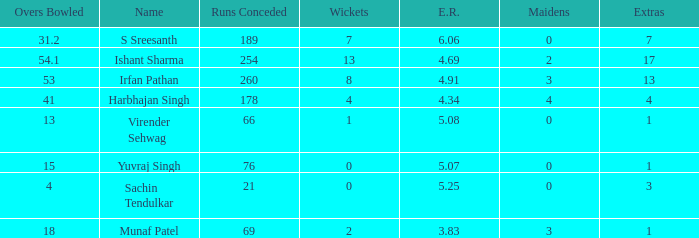Could you help me parse every detail presented in this table? {'header': ['Overs Bowled', 'Name', 'Runs Conceded', 'Wickets', 'E.R.', 'Maidens', 'Extras'], 'rows': [['31.2', 'S Sreesanth', '189', '7', '6.06', '0', '7'], ['54.1', 'Ishant Sharma', '254', '13', '4.69', '2', '17'], ['53', 'Irfan Pathan', '260', '8', '4.91', '3', '13'], ['41', 'Harbhajan Singh', '178', '4', '4.34', '4', '4'], ['13', 'Virender Sehwag', '66', '1', '5.08', '0', '1'], ['15', 'Yuvraj Singh', '76', '0', '5.07', '0', '1'], ['4', 'Sachin Tendulkar', '21', '0', '5.25', '0', '3'], ['18', 'Munaf Patel', '69', '2', '3.83', '3', '1']]} Name the wickets for overs bowled being 15 0.0. 